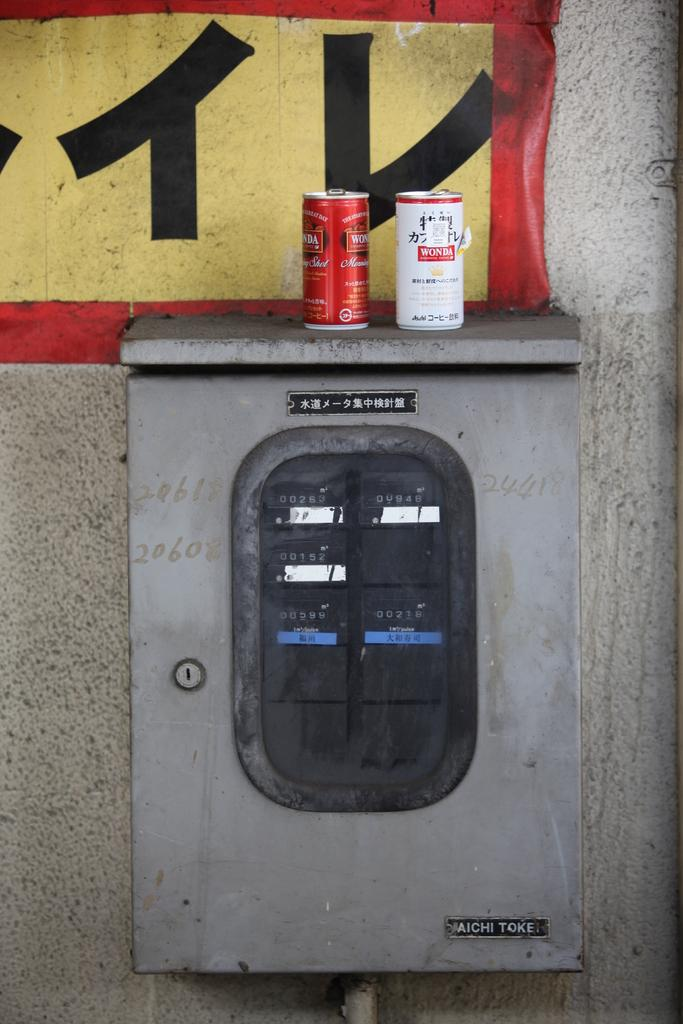Provide a one-sentence caption for the provided image. A couple of Wonda cans atop an Aichi Tokei electrical box. 